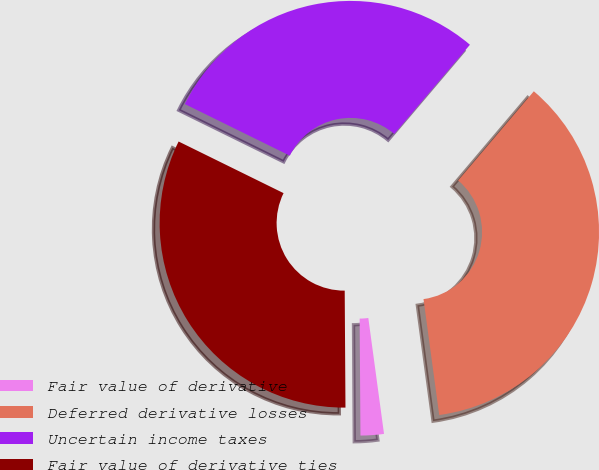Convert chart to OTSL. <chart><loc_0><loc_0><loc_500><loc_500><pie_chart><fcel>Fair value of derivative<fcel>Deferred derivative losses<fcel>Uncertain income taxes<fcel>Fair value of derivative ties<nl><fcel>2.04%<fcel>36.66%<fcel>28.92%<fcel>32.38%<nl></chart> 